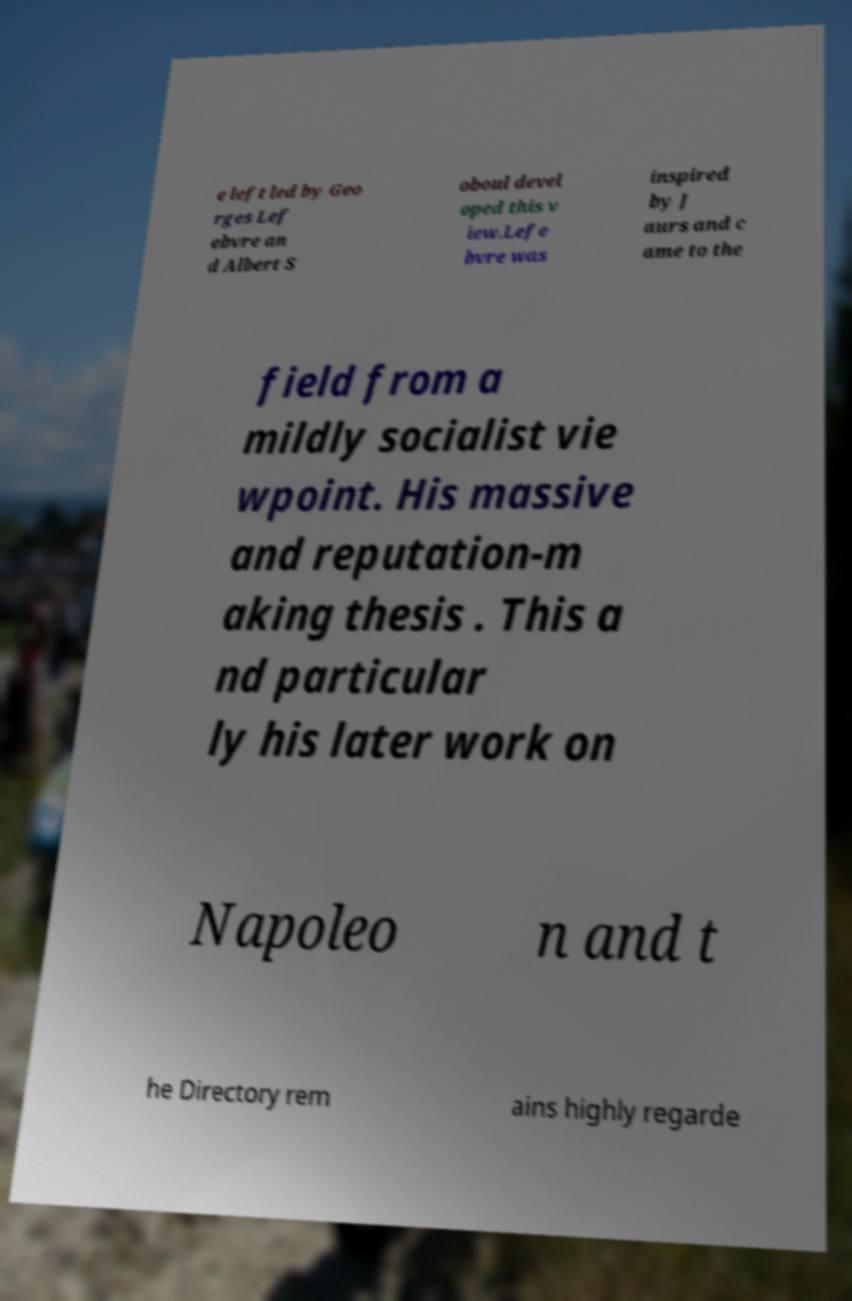Could you extract and type out the text from this image? e left led by Geo rges Lef ebvre an d Albert S oboul devel oped this v iew.Lefe bvre was inspired by J aurs and c ame to the field from a mildly socialist vie wpoint. His massive and reputation-m aking thesis . This a nd particular ly his later work on Napoleo n and t he Directory rem ains highly regarde 